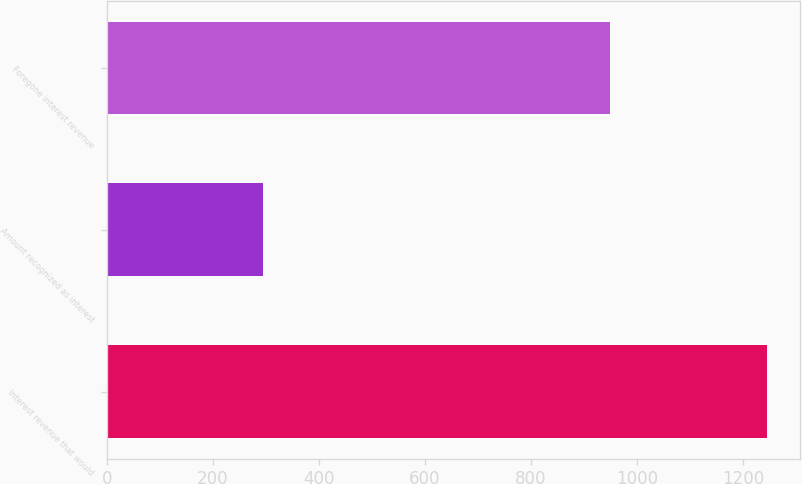<chart> <loc_0><loc_0><loc_500><loc_500><bar_chart><fcel>Interest revenue that would<fcel>Amount recognized as interest<fcel>Foregone interest revenue<nl><fcel>1245<fcel>295<fcel>950<nl></chart> 